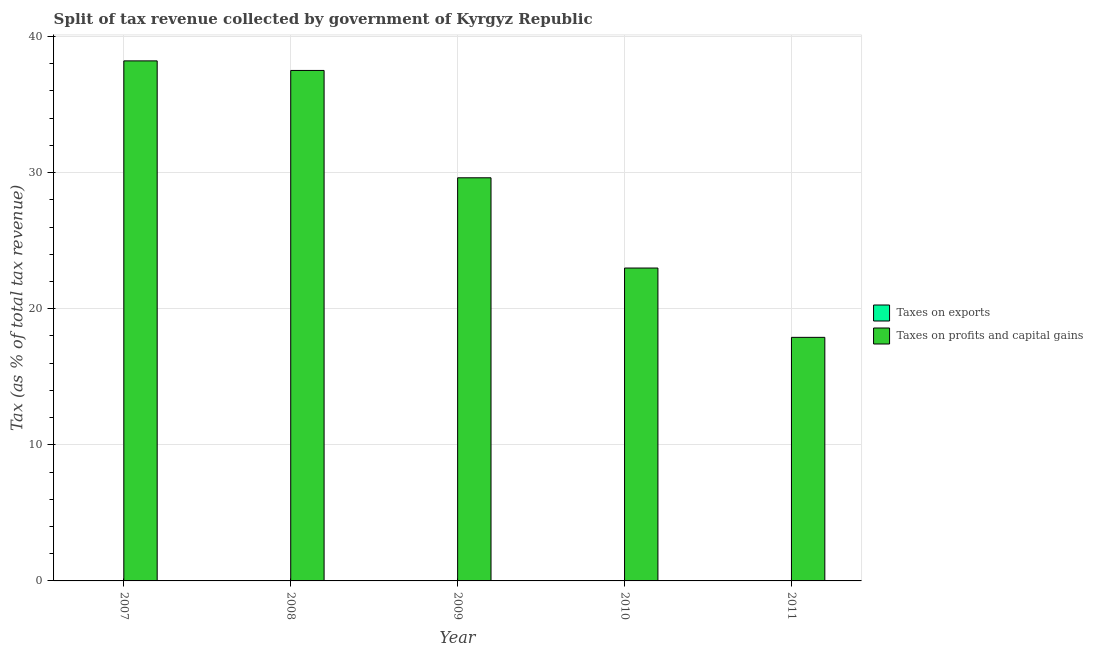What is the percentage of revenue obtained from taxes on exports in 2008?
Keep it short and to the point. 0.01. Across all years, what is the maximum percentage of revenue obtained from taxes on exports?
Offer a terse response. 0.02. In which year was the percentage of revenue obtained from taxes on profits and capital gains maximum?
Offer a terse response. 2007. What is the total percentage of revenue obtained from taxes on exports in the graph?
Keep it short and to the point. 0.04. What is the difference between the percentage of revenue obtained from taxes on exports in 2008 and that in 2010?
Provide a short and direct response. -0.01. What is the difference between the percentage of revenue obtained from taxes on profits and capital gains in 2009 and the percentage of revenue obtained from taxes on exports in 2007?
Make the answer very short. -8.59. What is the average percentage of revenue obtained from taxes on profits and capital gains per year?
Your answer should be compact. 29.24. In the year 2008, what is the difference between the percentage of revenue obtained from taxes on exports and percentage of revenue obtained from taxes on profits and capital gains?
Keep it short and to the point. 0. What is the ratio of the percentage of revenue obtained from taxes on profits and capital gains in 2009 to that in 2011?
Your response must be concise. 1.66. Is the percentage of revenue obtained from taxes on profits and capital gains in 2007 less than that in 2010?
Keep it short and to the point. No. What is the difference between the highest and the second highest percentage of revenue obtained from taxes on profits and capital gains?
Your answer should be compact. 0.7. What is the difference between the highest and the lowest percentage of revenue obtained from taxes on profits and capital gains?
Your response must be concise. 20.31. How many bars are there?
Provide a succinct answer. 9. Are all the bars in the graph horizontal?
Your answer should be compact. No. What is the difference between two consecutive major ticks on the Y-axis?
Provide a short and direct response. 10. Does the graph contain any zero values?
Your answer should be compact. Yes. Does the graph contain grids?
Your answer should be compact. Yes. Where does the legend appear in the graph?
Provide a short and direct response. Center right. How many legend labels are there?
Your answer should be compact. 2. What is the title of the graph?
Provide a succinct answer. Split of tax revenue collected by government of Kyrgyz Republic. What is the label or title of the Y-axis?
Make the answer very short. Tax (as % of total tax revenue). What is the Tax (as % of total tax revenue) in Taxes on exports in 2007?
Offer a terse response. 0. What is the Tax (as % of total tax revenue) of Taxes on profits and capital gains in 2007?
Make the answer very short. 38.21. What is the Tax (as % of total tax revenue) in Taxes on exports in 2008?
Ensure brevity in your answer.  0.01. What is the Tax (as % of total tax revenue) in Taxes on profits and capital gains in 2008?
Ensure brevity in your answer.  37.5. What is the Tax (as % of total tax revenue) in Taxes on exports in 2009?
Make the answer very short. 0.01. What is the Tax (as % of total tax revenue) in Taxes on profits and capital gains in 2009?
Offer a terse response. 29.62. What is the Tax (as % of total tax revenue) of Taxes on exports in 2010?
Your answer should be very brief. 0.02. What is the Tax (as % of total tax revenue) of Taxes on profits and capital gains in 2010?
Provide a succinct answer. 22.99. What is the Tax (as % of total tax revenue) in Taxes on profits and capital gains in 2011?
Your response must be concise. 17.89. Across all years, what is the maximum Tax (as % of total tax revenue) of Taxes on exports?
Your answer should be compact. 0.02. Across all years, what is the maximum Tax (as % of total tax revenue) of Taxes on profits and capital gains?
Ensure brevity in your answer.  38.21. Across all years, what is the minimum Tax (as % of total tax revenue) of Taxes on profits and capital gains?
Your response must be concise. 17.89. What is the total Tax (as % of total tax revenue) in Taxes on exports in the graph?
Your response must be concise. 0.04. What is the total Tax (as % of total tax revenue) of Taxes on profits and capital gains in the graph?
Your answer should be very brief. 146.2. What is the difference between the Tax (as % of total tax revenue) in Taxes on exports in 2007 and that in 2008?
Give a very brief answer. -0.01. What is the difference between the Tax (as % of total tax revenue) of Taxes on profits and capital gains in 2007 and that in 2008?
Make the answer very short. 0.7. What is the difference between the Tax (as % of total tax revenue) in Taxes on exports in 2007 and that in 2009?
Ensure brevity in your answer.  -0.01. What is the difference between the Tax (as % of total tax revenue) in Taxes on profits and capital gains in 2007 and that in 2009?
Make the answer very short. 8.59. What is the difference between the Tax (as % of total tax revenue) of Taxes on exports in 2007 and that in 2010?
Give a very brief answer. -0.02. What is the difference between the Tax (as % of total tax revenue) of Taxes on profits and capital gains in 2007 and that in 2010?
Make the answer very short. 15.22. What is the difference between the Tax (as % of total tax revenue) of Taxes on profits and capital gains in 2007 and that in 2011?
Offer a very short reply. 20.31. What is the difference between the Tax (as % of total tax revenue) of Taxes on exports in 2008 and that in 2009?
Keep it short and to the point. -0.01. What is the difference between the Tax (as % of total tax revenue) of Taxes on profits and capital gains in 2008 and that in 2009?
Give a very brief answer. 7.89. What is the difference between the Tax (as % of total tax revenue) of Taxes on exports in 2008 and that in 2010?
Offer a terse response. -0.01. What is the difference between the Tax (as % of total tax revenue) of Taxes on profits and capital gains in 2008 and that in 2010?
Provide a short and direct response. 14.52. What is the difference between the Tax (as % of total tax revenue) in Taxes on profits and capital gains in 2008 and that in 2011?
Make the answer very short. 19.61. What is the difference between the Tax (as % of total tax revenue) of Taxes on exports in 2009 and that in 2010?
Provide a succinct answer. -0.01. What is the difference between the Tax (as % of total tax revenue) in Taxes on profits and capital gains in 2009 and that in 2010?
Your response must be concise. 6.63. What is the difference between the Tax (as % of total tax revenue) of Taxes on profits and capital gains in 2009 and that in 2011?
Offer a terse response. 11.72. What is the difference between the Tax (as % of total tax revenue) in Taxes on profits and capital gains in 2010 and that in 2011?
Make the answer very short. 5.09. What is the difference between the Tax (as % of total tax revenue) of Taxes on exports in 2007 and the Tax (as % of total tax revenue) of Taxes on profits and capital gains in 2008?
Your answer should be compact. -37.5. What is the difference between the Tax (as % of total tax revenue) of Taxes on exports in 2007 and the Tax (as % of total tax revenue) of Taxes on profits and capital gains in 2009?
Your answer should be very brief. -29.62. What is the difference between the Tax (as % of total tax revenue) in Taxes on exports in 2007 and the Tax (as % of total tax revenue) in Taxes on profits and capital gains in 2010?
Keep it short and to the point. -22.99. What is the difference between the Tax (as % of total tax revenue) of Taxes on exports in 2007 and the Tax (as % of total tax revenue) of Taxes on profits and capital gains in 2011?
Your response must be concise. -17.89. What is the difference between the Tax (as % of total tax revenue) in Taxes on exports in 2008 and the Tax (as % of total tax revenue) in Taxes on profits and capital gains in 2009?
Provide a short and direct response. -29.61. What is the difference between the Tax (as % of total tax revenue) of Taxes on exports in 2008 and the Tax (as % of total tax revenue) of Taxes on profits and capital gains in 2010?
Offer a very short reply. -22.98. What is the difference between the Tax (as % of total tax revenue) in Taxes on exports in 2008 and the Tax (as % of total tax revenue) in Taxes on profits and capital gains in 2011?
Make the answer very short. -17.89. What is the difference between the Tax (as % of total tax revenue) in Taxes on exports in 2009 and the Tax (as % of total tax revenue) in Taxes on profits and capital gains in 2010?
Your answer should be very brief. -22.97. What is the difference between the Tax (as % of total tax revenue) in Taxes on exports in 2009 and the Tax (as % of total tax revenue) in Taxes on profits and capital gains in 2011?
Make the answer very short. -17.88. What is the difference between the Tax (as % of total tax revenue) of Taxes on exports in 2010 and the Tax (as % of total tax revenue) of Taxes on profits and capital gains in 2011?
Keep it short and to the point. -17.88. What is the average Tax (as % of total tax revenue) in Taxes on exports per year?
Give a very brief answer. 0.01. What is the average Tax (as % of total tax revenue) of Taxes on profits and capital gains per year?
Your response must be concise. 29.24. In the year 2007, what is the difference between the Tax (as % of total tax revenue) of Taxes on exports and Tax (as % of total tax revenue) of Taxes on profits and capital gains?
Offer a very short reply. -38.2. In the year 2008, what is the difference between the Tax (as % of total tax revenue) in Taxes on exports and Tax (as % of total tax revenue) in Taxes on profits and capital gains?
Make the answer very short. -37.5. In the year 2009, what is the difference between the Tax (as % of total tax revenue) in Taxes on exports and Tax (as % of total tax revenue) in Taxes on profits and capital gains?
Your answer should be compact. -29.6. In the year 2010, what is the difference between the Tax (as % of total tax revenue) of Taxes on exports and Tax (as % of total tax revenue) of Taxes on profits and capital gains?
Your answer should be compact. -22.97. What is the ratio of the Tax (as % of total tax revenue) of Taxes on exports in 2007 to that in 2008?
Offer a terse response. 0.11. What is the ratio of the Tax (as % of total tax revenue) of Taxes on profits and capital gains in 2007 to that in 2008?
Offer a very short reply. 1.02. What is the ratio of the Tax (as % of total tax revenue) of Taxes on exports in 2007 to that in 2009?
Offer a very short reply. 0.05. What is the ratio of the Tax (as % of total tax revenue) in Taxes on profits and capital gains in 2007 to that in 2009?
Offer a very short reply. 1.29. What is the ratio of the Tax (as % of total tax revenue) of Taxes on exports in 2007 to that in 2010?
Make the answer very short. 0.04. What is the ratio of the Tax (as % of total tax revenue) in Taxes on profits and capital gains in 2007 to that in 2010?
Your response must be concise. 1.66. What is the ratio of the Tax (as % of total tax revenue) in Taxes on profits and capital gains in 2007 to that in 2011?
Ensure brevity in your answer.  2.14. What is the ratio of the Tax (as % of total tax revenue) in Taxes on exports in 2008 to that in 2009?
Ensure brevity in your answer.  0.49. What is the ratio of the Tax (as % of total tax revenue) in Taxes on profits and capital gains in 2008 to that in 2009?
Provide a short and direct response. 1.27. What is the ratio of the Tax (as % of total tax revenue) in Taxes on exports in 2008 to that in 2010?
Ensure brevity in your answer.  0.33. What is the ratio of the Tax (as % of total tax revenue) in Taxes on profits and capital gains in 2008 to that in 2010?
Offer a terse response. 1.63. What is the ratio of the Tax (as % of total tax revenue) in Taxes on profits and capital gains in 2008 to that in 2011?
Offer a very short reply. 2.1. What is the ratio of the Tax (as % of total tax revenue) in Taxes on exports in 2009 to that in 2010?
Ensure brevity in your answer.  0.66. What is the ratio of the Tax (as % of total tax revenue) in Taxes on profits and capital gains in 2009 to that in 2010?
Your response must be concise. 1.29. What is the ratio of the Tax (as % of total tax revenue) in Taxes on profits and capital gains in 2009 to that in 2011?
Provide a short and direct response. 1.66. What is the ratio of the Tax (as % of total tax revenue) of Taxes on profits and capital gains in 2010 to that in 2011?
Give a very brief answer. 1.28. What is the difference between the highest and the second highest Tax (as % of total tax revenue) of Taxes on exports?
Provide a short and direct response. 0.01. What is the difference between the highest and the second highest Tax (as % of total tax revenue) in Taxes on profits and capital gains?
Ensure brevity in your answer.  0.7. What is the difference between the highest and the lowest Tax (as % of total tax revenue) of Taxes on exports?
Your answer should be very brief. 0.02. What is the difference between the highest and the lowest Tax (as % of total tax revenue) in Taxes on profits and capital gains?
Make the answer very short. 20.31. 